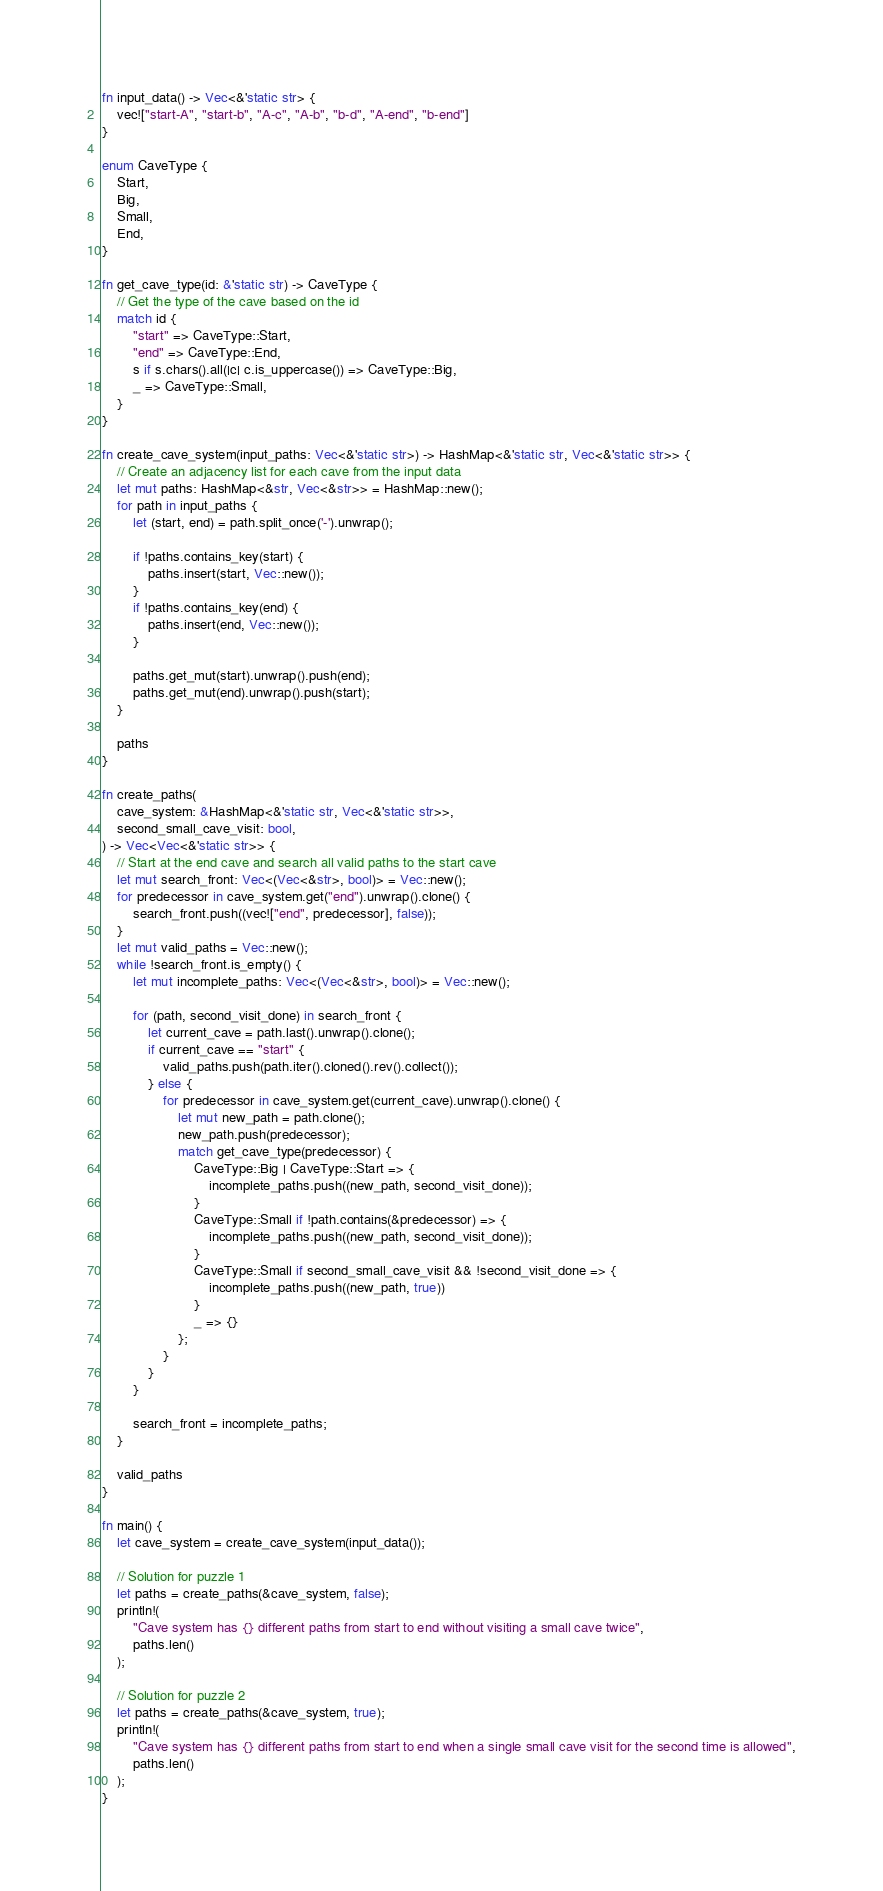Convert code to text. <code><loc_0><loc_0><loc_500><loc_500><_Rust_>
fn input_data() -> Vec<&'static str> {
    vec!["start-A", "start-b", "A-c", "A-b", "b-d", "A-end", "b-end"]
}

enum CaveType {
    Start,
    Big,
    Small,
    End,
}

fn get_cave_type(id: &'static str) -> CaveType {
    // Get the type of the cave based on the id
    match id {
        "start" => CaveType::Start,
        "end" => CaveType::End,
        s if s.chars().all(|c| c.is_uppercase()) => CaveType::Big,
        _ => CaveType::Small,
    }
}

fn create_cave_system(input_paths: Vec<&'static str>) -> HashMap<&'static str, Vec<&'static str>> {
    // Create an adjacency list for each cave from the input data
    let mut paths: HashMap<&str, Vec<&str>> = HashMap::new();
    for path in input_paths {
        let (start, end) = path.split_once('-').unwrap();

        if !paths.contains_key(start) {
            paths.insert(start, Vec::new());
        }
        if !paths.contains_key(end) {
            paths.insert(end, Vec::new());
        }

        paths.get_mut(start).unwrap().push(end);
        paths.get_mut(end).unwrap().push(start);
    }

    paths
}

fn create_paths(
    cave_system: &HashMap<&'static str, Vec<&'static str>>,
    second_small_cave_visit: bool,
) -> Vec<Vec<&'static str>> {
    // Start at the end cave and search all valid paths to the start cave
    let mut search_front: Vec<(Vec<&str>, bool)> = Vec::new();
    for predecessor in cave_system.get("end").unwrap().clone() {
        search_front.push((vec!["end", predecessor], false));
    }
    let mut valid_paths = Vec::new();
    while !search_front.is_empty() {
        let mut incomplete_paths: Vec<(Vec<&str>, bool)> = Vec::new();

        for (path, second_visit_done) in search_front {
            let current_cave = path.last().unwrap().clone();
            if current_cave == "start" {
                valid_paths.push(path.iter().cloned().rev().collect());
            } else {
                for predecessor in cave_system.get(current_cave).unwrap().clone() {
                    let mut new_path = path.clone();
                    new_path.push(predecessor);
                    match get_cave_type(predecessor) {
                        CaveType::Big | CaveType::Start => {
                            incomplete_paths.push((new_path, second_visit_done));
                        }
                        CaveType::Small if !path.contains(&predecessor) => {
                            incomplete_paths.push((new_path, second_visit_done));
                        }
                        CaveType::Small if second_small_cave_visit && !second_visit_done => {
                            incomplete_paths.push((new_path, true))
                        }
                        _ => {}
                    };
                }
            }
        }

        search_front = incomplete_paths;
    }

    valid_paths
}

fn main() {
    let cave_system = create_cave_system(input_data());

    // Solution for puzzle 1
    let paths = create_paths(&cave_system, false);
    println!(
        "Cave system has {} different paths from start to end without visiting a small cave twice",
        paths.len()
    );

    // Solution for puzzle 2
    let paths = create_paths(&cave_system, true);
    println!(
        "Cave system has {} different paths from start to end when a single small cave visit for the second time is allowed",
        paths.len()
    );
}
</code> 